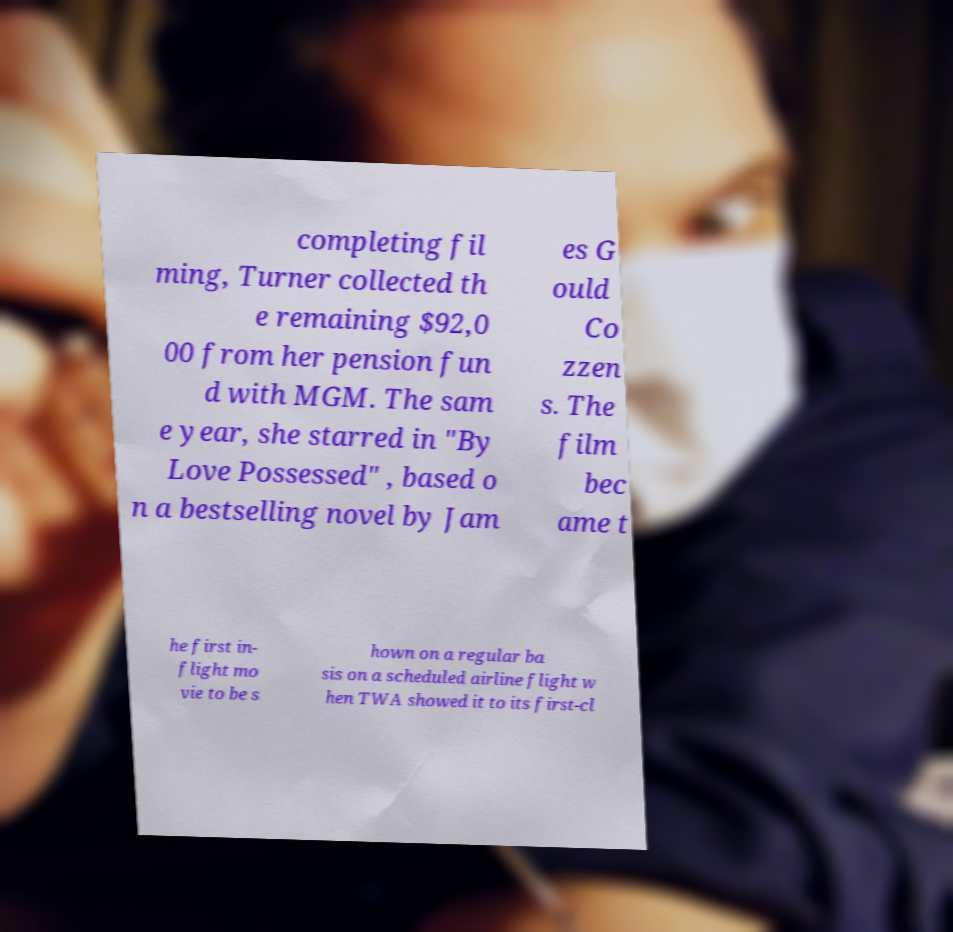Could you assist in decoding the text presented in this image and type it out clearly? completing fil ming, Turner collected th e remaining $92,0 00 from her pension fun d with MGM. The sam e year, she starred in "By Love Possessed" , based o n a bestselling novel by Jam es G ould Co zzen s. The film bec ame t he first in- flight mo vie to be s hown on a regular ba sis on a scheduled airline flight w hen TWA showed it to its first-cl 